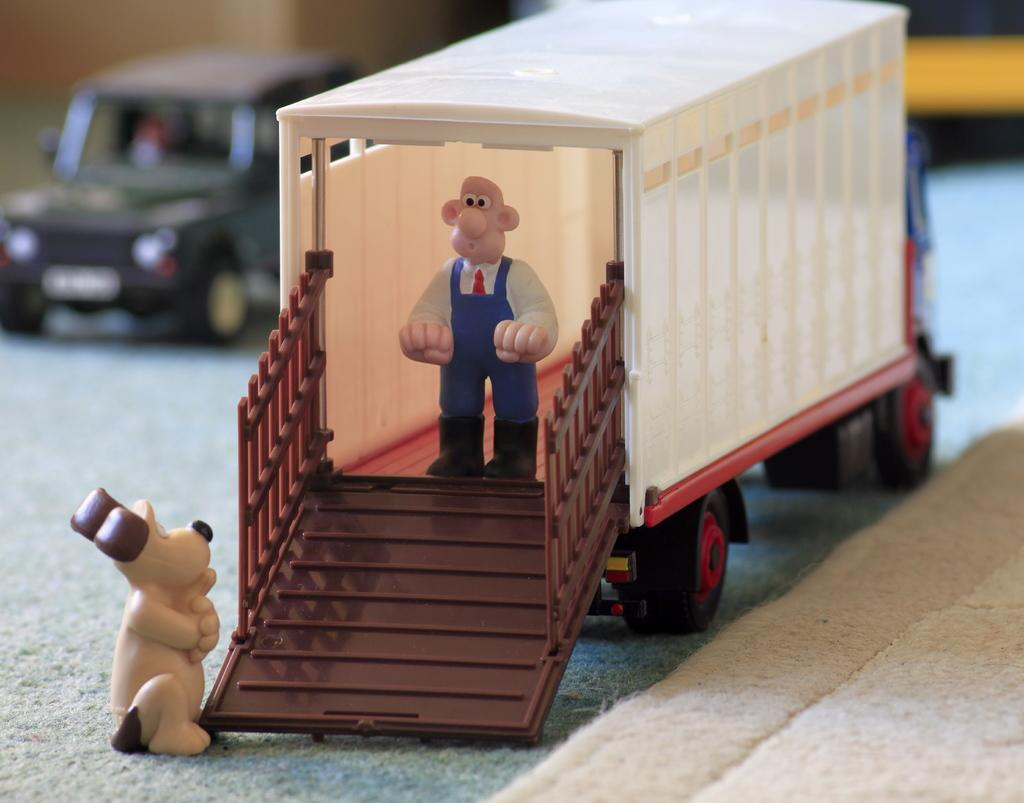What type of toys are on the platform in the image? There are toy vehicles on a platform in the image. Can you describe the position of the toy person in the image? The toy person is standing in a truck, which is part of the toy vehicles. What other toy is present near the toy vehicles? There is a toy dog at the vehicle door. What type of crack can be seen in the image? There is no crack present in the image. What is the slope of the platform in the image? The platform in the image does not have a slope; it is flat. 